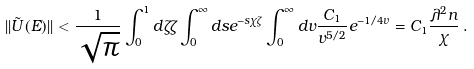<formula> <loc_0><loc_0><loc_500><loc_500>| | \tilde { U } ( E ) | | < \frac { 1 } { \sqrt { \pi } } \int _ { 0 } ^ { 1 } d \zeta \zeta \int _ { 0 } ^ { \infty } d s e ^ { - s \chi \zeta } \int _ { 0 } ^ { \infty } d v \frac { C _ { 1 } } { v ^ { 5 / 2 } } e ^ { - 1 / 4 v } = C _ { 1 } \frac { \lambda ^ { 2 } n } { \chi } \, .</formula> 